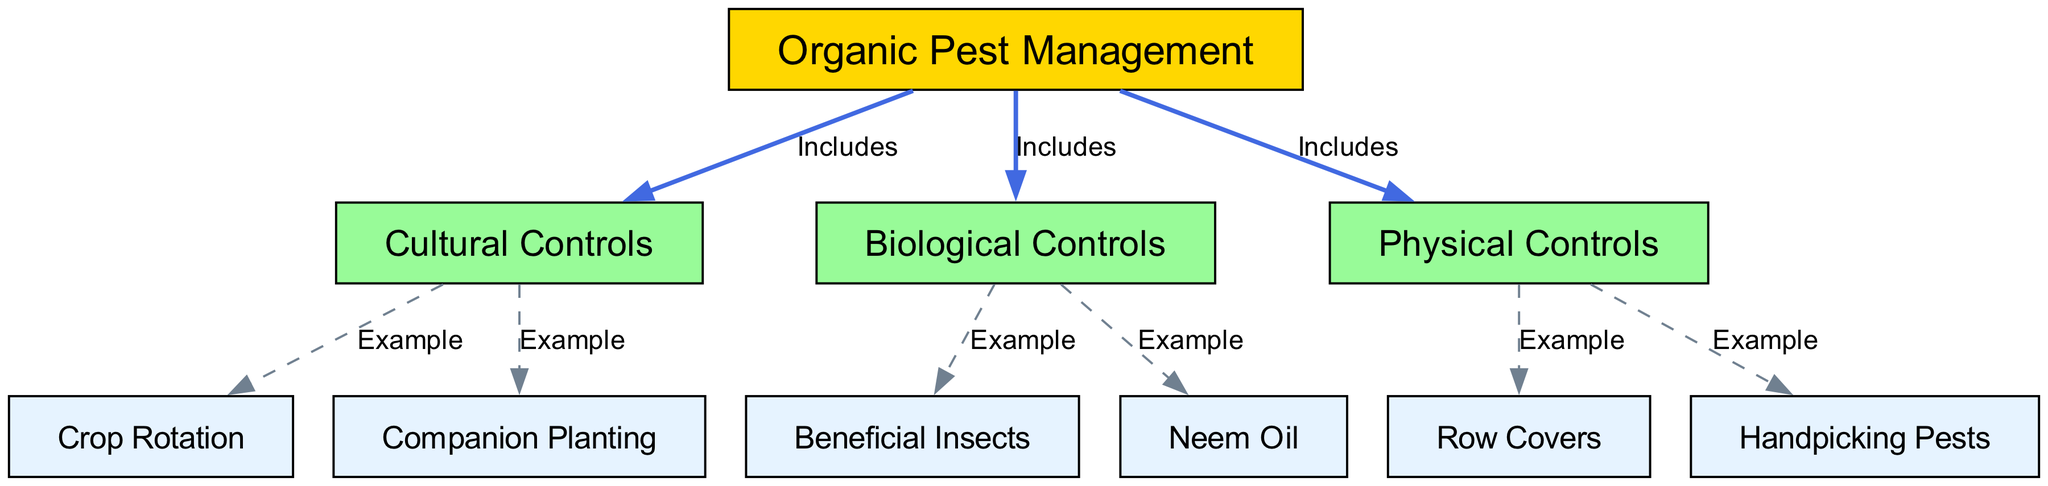What is the central theme of the diagram? The diagram centers around "Organic Pest Management," which is indicated as the primary node at the top labeled with the id '1'. This node represents the overarching concept that encompasses the various pest management strategies displayed in the diagram.
Answer: Organic Pest Management How many main pest management strategies are included in the diagram? There are three main pest management strategies listed: "Cultural Controls," "Biological Controls," and "Physical Controls," represented by nodes '2', '3', and '4' respectively.
Answer: Three Which strategy includes "Crop Rotation"? "Crop Rotation" is an example of a strategy that falls under "Cultural Controls" as indicated by the edge from node '2' to node '5', labeled as an example. This shows that "Crop Rotation" is a specific method within this broader category.
Answer: Cultural Controls What type of control is "Neem Oil"? "Neem Oil" is classified under "Biological Controls," as shown by the edge from node '3' to node '8', where it is highlighted as an example of biological pest management tools.
Answer: Biological Controls List an example of a physical control method mentioned in the diagram. The diagram lists "Row Covers" and "Handpicking Pests" as examples of Physical Controls, both connected to the "Physical Controls" node ('4') via labeled edges indicating their relationship as examples.
Answer: Row Covers What is the relationship between "Beneficial Insects" and "Organic Pest Management"? "Beneficial Insects" is an example of "Biological Controls" and is connected to the main node "Organic Pest Management" through the edge labeled "Includes," illustrating that beneficial insects are part of the organic pest management strategies.
Answer: Includes How many examples are given under "Physical Controls"? There are two examples provided under "Physical Controls": "Row Covers" and "Handpicking Pests," as indicated by the connections from node '4' to nodes '9' and '10'.
Answer: Two What specific control strategy involves the method of "Companion Planting"? "Companion Planting" is specified as an example under "Cultural Controls," represented by the edge from node '2' to node '6'. This shows its role in pest management through strategic planting relationships.
Answer: Cultural Controls 